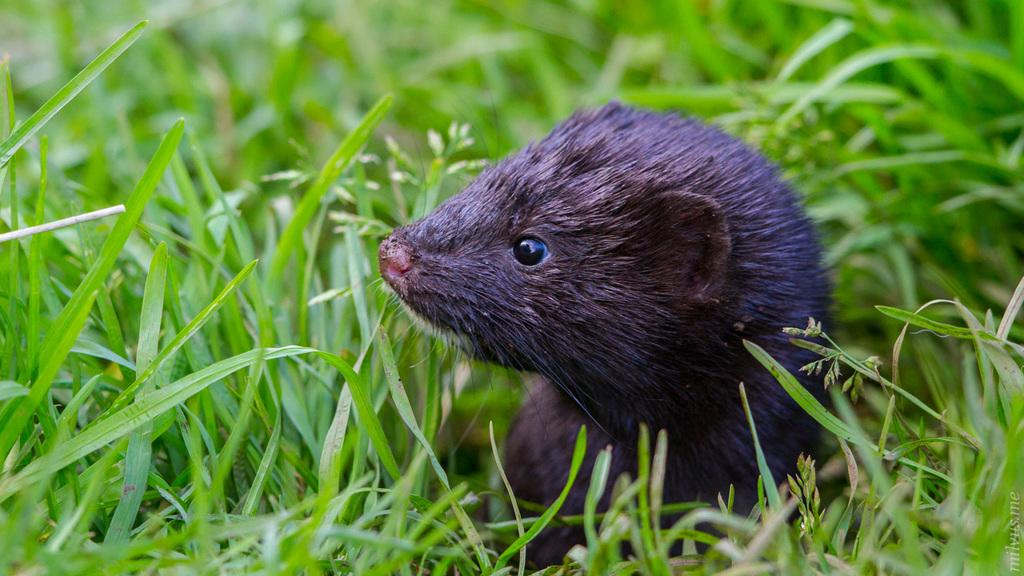What type of animal can be seen in the image? There is an animal in the image, but its specific type cannot be determined from the provided facts. Where is the animal located in relation to the grass? The animal is in between the grass in the image. What type of vegetation is visible on the floor in the image? There is grass visible on the floor in the image. How many kittens are playing with the wax on the hill in the image? There is no hill, wax, or kittens present in the image. 